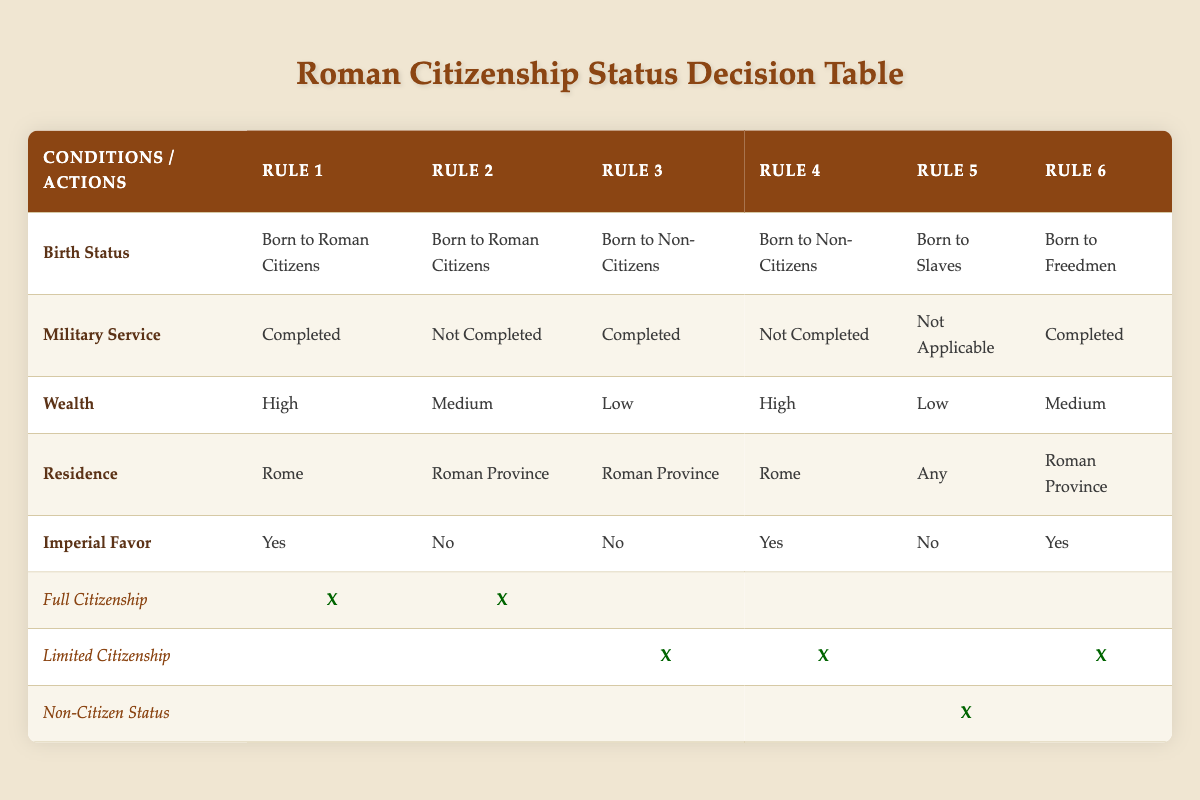What is the birth status for individuals who have completed military service and live in Rome? According to the table, individuals who have completed military service and reside in Rome are either "Born to Roman Citizens" or "Born to Non-Citizens."
Answer: Born to Roman Citizens or Born to Non-Citizens How many rules grant Full Citizenship? There are 2 rules that grant Full Citizenship. Rules 1 and 2 indicate "X" under the Full Citizenship action.
Answer: 2 Is wealth a factor in determining Limited Citizenship status? Yes, wealth does play a role in determining Limited Citizenship. The rules indicate Limited Citizenship can be granted to individuals with Low and Medium wealth.
Answer: Yes What is the required residence status for someone born to Non-Citizens to attain Limited Citizenship? Individuals born to Non-Citizens require residence in either Rome or Roman Province to achieve Limited Citizenship, as seen in Rules 3 and 4.
Answer: Rome or Roman Province For someone born to Slaves, what status do they hold? According to Rule 5, individuals born to Slaves have Non-Citizen Status as indicated by "X" under Non-Citizen Status action.
Answer: Non-Citizen Status Which combination of conditions leads to Limited Citizenship? The combinations leading to Limited Citizenship are: 1) Born to Non-Citizens with completed military service, low wealth, and residence in Roman Province (Rule 3), 2) Born to Non-Citizens with not completed military service, high wealth, and residence in Rome (Rule 4), and 3) Born to Freedmen with completed military service, medium wealth, and residence in Roman Province (Rule 6).
Answer: Non-Citizen with completed military service and Freedmen with completed military service What is the significance of Imperial Favor in determining citizenship? Imperial Favor significantly impacts citizenship. Rules show that Full Citizenship is granted to those with Imperial Favor, while Limited Citizenship is provided based on various wealth and military conditions, leading to a more complex evaluation.
Answer: Significant impact on citizenship status How many citizenship statuses are possible based on this table? There are three possible citizenship statuses: Full Citizenship, Limited Citizenship, and Non-Citizen Status as highlighted in the actions section of the table.
Answer: Three statuses Which rule is the only one that results in Non-Citizen Status? Rule 5 is the only one that results in Non-Citizen Status, as it shows an "X" in the Non-Citizen Status column and represents individuals born to Slaves.
Answer: Rule 5 